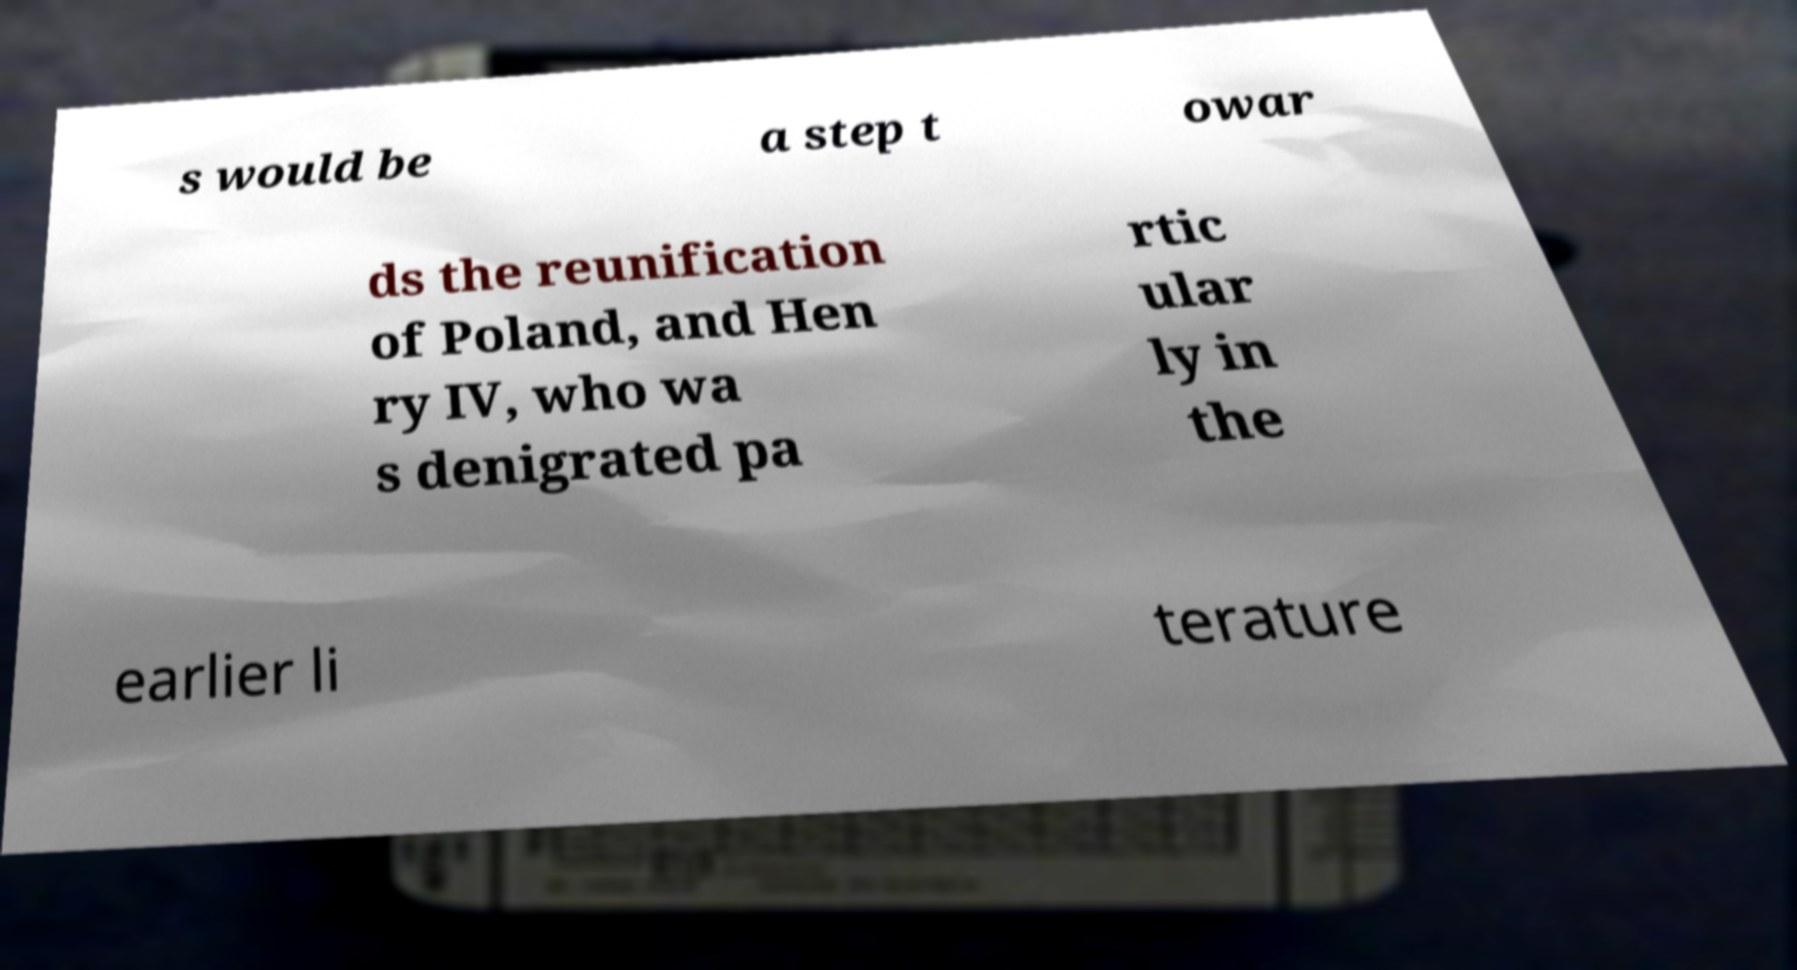I need the written content from this picture converted into text. Can you do that? s would be a step t owar ds the reunification of Poland, and Hen ry IV, who wa s denigrated pa rtic ular ly in the earlier li terature 